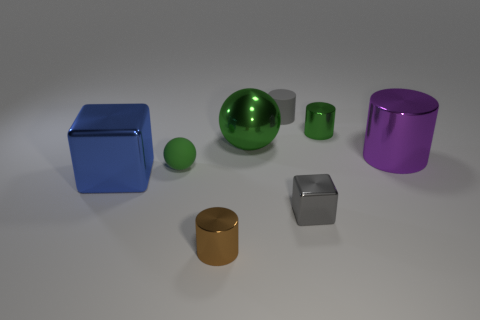Are there fewer big metallic cylinders to the left of the big green object than purple metal objects on the left side of the blue thing? Based on the image, there is one large metallic cylinder to the left of the big green sphere and one purple metallic cylinder on the left side of the blue cube. Therefore, the number of big metallic cylinders to the left of the green object is equal to the number of purple metallic objects to the left of the blue object. 